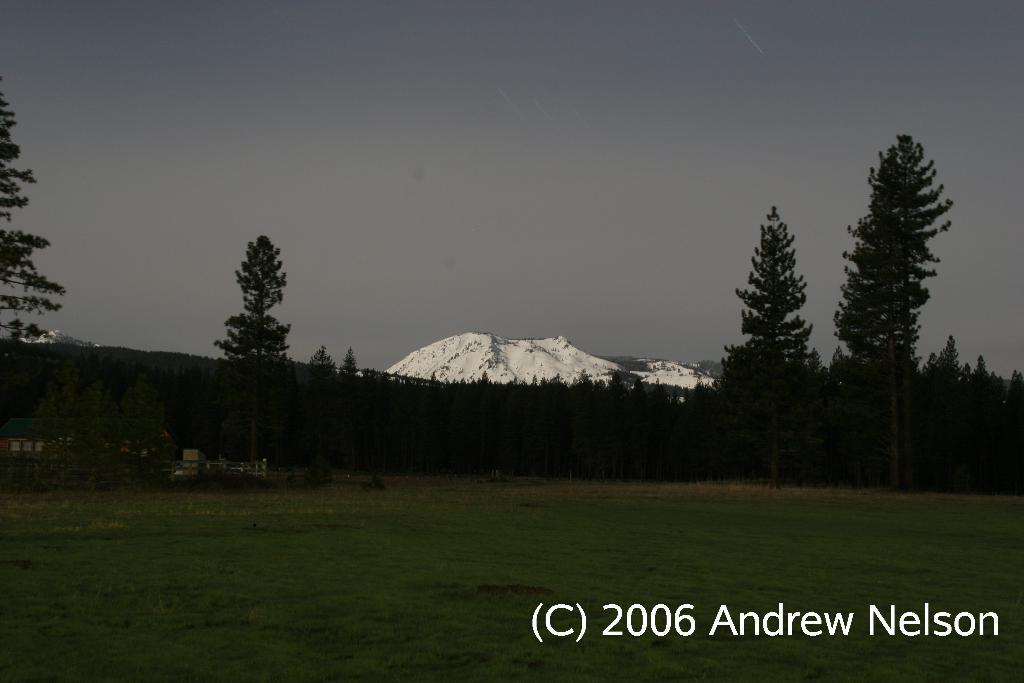What type of vegetation is present in the image? There is a group of trees and grass in the image. What type of barrier can be seen in the image? There is a fence in the image. What type of natural formations are present in the image? There are ice hills in the image. What is the condition of the sky in the image? The sky is visible in the image and appears cloudy. What is written at the bottom of the image? There is some text at the bottom of the image. Can you tell me how many tickets are visible in the image? There are no tickets present in the image. What type of pain is being experienced by the trees in the image? There is no indication of pain in the image, and trees do not experience pain. 